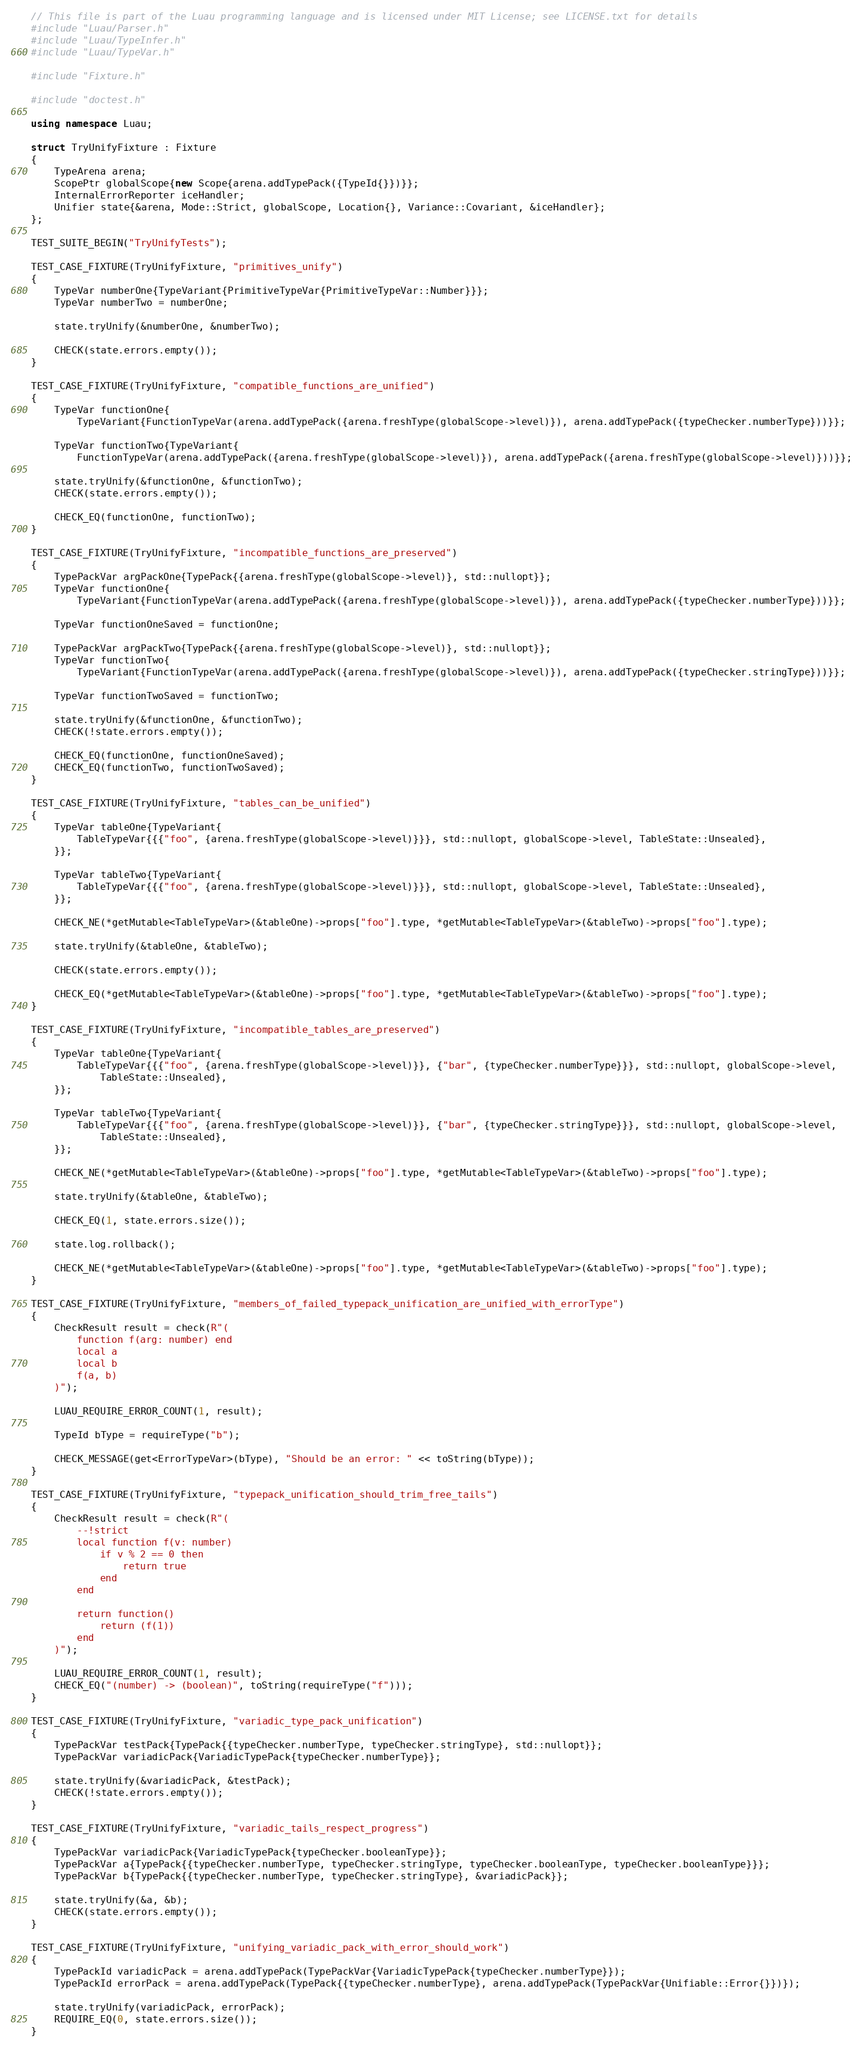Convert code to text. <code><loc_0><loc_0><loc_500><loc_500><_C++_>// This file is part of the Luau programming language and is licensed under MIT License; see LICENSE.txt for details
#include "Luau/Parser.h"
#include "Luau/TypeInfer.h"
#include "Luau/TypeVar.h"

#include "Fixture.h"

#include "doctest.h"

using namespace Luau;

struct TryUnifyFixture : Fixture
{
    TypeArena arena;
    ScopePtr globalScope{new Scope{arena.addTypePack({TypeId{}})}};
    InternalErrorReporter iceHandler;
    Unifier state{&arena, Mode::Strict, globalScope, Location{}, Variance::Covariant, &iceHandler};
};

TEST_SUITE_BEGIN("TryUnifyTests");

TEST_CASE_FIXTURE(TryUnifyFixture, "primitives_unify")
{
    TypeVar numberOne{TypeVariant{PrimitiveTypeVar{PrimitiveTypeVar::Number}}};
    TypeVar numberTwo = numberOne;

    state.tryUnify(&numberOne, &numberTwo);

    CHECK(state.errors.empty());
}

TEST_CASE_FIXTURE(TryUnifyFixture, "compatible_functions_are_unified")
{
    TypeVar functionOne{
        TypeVariant{FunctionTypeVar(arena.addTypePack({arena.freshType(globalScope->level)}), arena.addTypePack({typeChecker.numberType}))}};

    TypeVar functionTwo{TypeVariant{
        FunctionTypeVar(arena.addTypePack({arena.freshType(globalScope->level)}), arena.addTypePack({arena.freshType(globalScope->level)}))}};

    state.tryUnify(&functionOne, &functionTwo);
    CHECK(state.errors.empty());

    CHECK_EQ(functionOne, functionTwo);
}

TEST_CASE_FIXTURE(TryUnifyFixture, "incompatible_functions_are_preserved")
{
    TypePackVar argPackOne{TypePack{{arena.freshType(globalScope->level)}, std::nullopt}};
    TypeVar functionOne{
        TypeVariant{FunctionTypeVar(arena.addTypePack({arena.freshType(globalScope->level)}), arena.addTypePack({typeChecker.numberType}))}};

    TypeVar functionOneSaved = functionOne;

    TypePackVar argPackTwo{TypePack{{arena.freshType(globalScope->level)}, std::nullopt}};
    TypeVar functionTwo{
        TypeVariant{FunctionTypeVar(arena.addTypePack({arena.freshType(globalScope->level)}), arena.addTypePack({typeChecker.stringType}))}};

    TypeVar functionTwoSaved = functionTwo;

    state.tryUnify(&functionOne, &functionTwo);
    CHECK(!state.errors.empty());

    CHECK_EQ(functionOne, functionOneSaved);
    CHECK_EQ(functionTwo, functionTwoSaved);
}

TEST_CASE_FIXTURE(TryUnifyFixture, "tables_can_be_unified")
{
    TypeVar tableOne{TypeVariant{
        TableTypeVar{{{"foo", {arena.freshType(globalScope->level)}}}, std::nullopt, globalScope->level, TableState::Unsealed},
    }};

    TypeVar tableTwo{TypeVariant{
        TableTypeVar{{{"foo", {arena.freshType(globalScope->level)}}}, std::nullopt, globalScope->level, TableState::Unsealed},
    }};

    CHECK_NE(*getMutable<TableTypeVar>(&tableOne)->props["foo"].type, *getMutable<TableTypeVar>(&tableTwo)->props["foo"].type);

    state.tryUnify(&tableOne, &tableTwo);

    CHECK(state.errors.empty());

    CHECK_EQ(*getMutable<TableTypeVar>(&tableOne)->props["foo"].type, *getMutable<TableTypeVar>(&tableTwo)->props["foo"].type);
}

TEST_CASE_FIXTURE(TryUnifyFixture, "incompatible_tables_are_preserved")
{
    TypeVar tableOne{TypeVariant{
        TableTypeVar{{{"foo", {arena.freshType(globalScope->level)}}, {"bar", {typeChecker.numberType}}}, std::nullopt, globalScope->level,
            TableState::Unsealed},
    }};

    TypeVar tableTwo{TypeVariant{
        TableTypeVar{{{"foo", {arena.freshType(globalScope->level)}}, {"bar", {typeChecker.stringType}}}, std::nullopt, globalScope->level,
            TableState::Unsealed},
    }};

    CHECK_NE(*getMutable<TableTypeVar>(&tableOne)->props["foo"].type, *getMutable<TableTypeVar>(&tableTwo)->props["foo"].type);

    state.tryUnify(&tableOne, &tableTwo);

    CHECK_EQ(1, state.errors.size());

    state.log.rollback();

    CHECK_NE(*getMutable<TableTypeVar>(&tableOne)->props["foo"].type, *getMutable<TableTypeVar>(&tableTwo)->props["foo"].type);
}

TEST_CASE_FIXTURE(TryUnifyFixture, "members_of_failed_typepack_unification_are_unified_with_errorType")
{
    CheckResult result = check(R"(
        function f(arg: number) end
        local a
        local b
        f(a, b)
    )");

    LUAU_REQUIRE_ERROR_COUNT(1, result);

    TypeId bType = requireType("b");

    CHECK_MESSAGE(get<ErrorTypeVar>(bType), "Should be an error: " << toString(bType));
}

TEST_CASE_FIXTURE(TryUnifyFixture, "typepack_unification_should_trim_free_tails")
{
    CheckResult result = check(R"(
        --!strict
        local function f(v: number)
            if v % 2 == 0 then
                return true
            end
        end

        return function()
            return (f(1))
        end
    )");

    LUAU_REQUIRE_ERROR_COUNT(1, result);
    CHECK_EQ("(number) -> (boolean)", toString(requireType("f")));
}

TEST_CASE_FIXTURE(TryUnifyFixture, "variadic_type_pack_unification")
{
    TypePackVar testPack{TypePack{{typeChecker.numberType, typeChecker.stringType}, std::nullopt}};
    TypePackVar variadicPack{VariadicTypePack{typeChecker.numberType}};

    state.tryUnify(&variadicPack, &testPack);
    CHECK(!state.errors.empty());
}

TEST_CASE_FIXTURE(TryUnifyFixture, "variadic_tails_respect_progress")
{
    TypePackVar variadicPack{VariadicTypePack{typeChecker.booleanType}};
    TypePackVar a{TypePack{{typeChecker.numberType, typeChecker.stringType, typeChecker.booleanType, typeChecker.booleanType}}};
    TypePackVar b{TypePack{{typeChecker.numberType, typeChecker.stringType}, &variadicPack}};

    state.tryUnify(&a, &b);
    CHECK(state.errors.empty());
}

TEST_CASE_FIXTURE(TryUnifyFixture, "unifying_variadic_pack_with_error_should_work")
{
    TypePackId variadicPack = arena.addTypePack(TypePackVar{VariadicTypePack{typeChecker.numberType}});
    TypePackId errorPack = arena.addTypePack(TypePack{{typeChecker.numberType}, arena.addTypePack(TypePackVar{Unifiable::Error{}})});

    state.tryUnify(variadicPack, errorPack);
    REQUIRE_EQ(0, state.errors.size());
}
</code> 